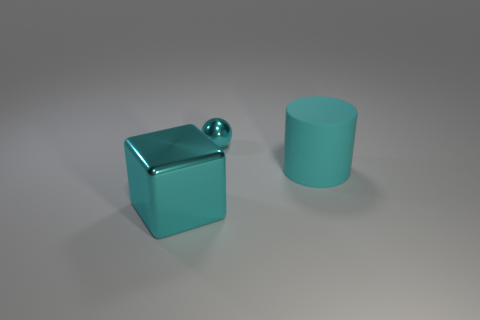Add 1 big objects. How many objects exist? 4 Subtract all spheres. How many objects are left? 2 Subtract 1 cubes. How many cubes are left? 0 Subtract all green cylinders. Subtract all brown spheres. How many cylinders are left? 1 Subtract all large things. Subtract all gray blocks. How many objects are left? 1 Add 2 large cyan cubes. How many large cyan cubes are left? 3 Add 2 cyan balls. How many cyan balls exist? 3 Subtract 0 blue balls. How many objects are left? 3 